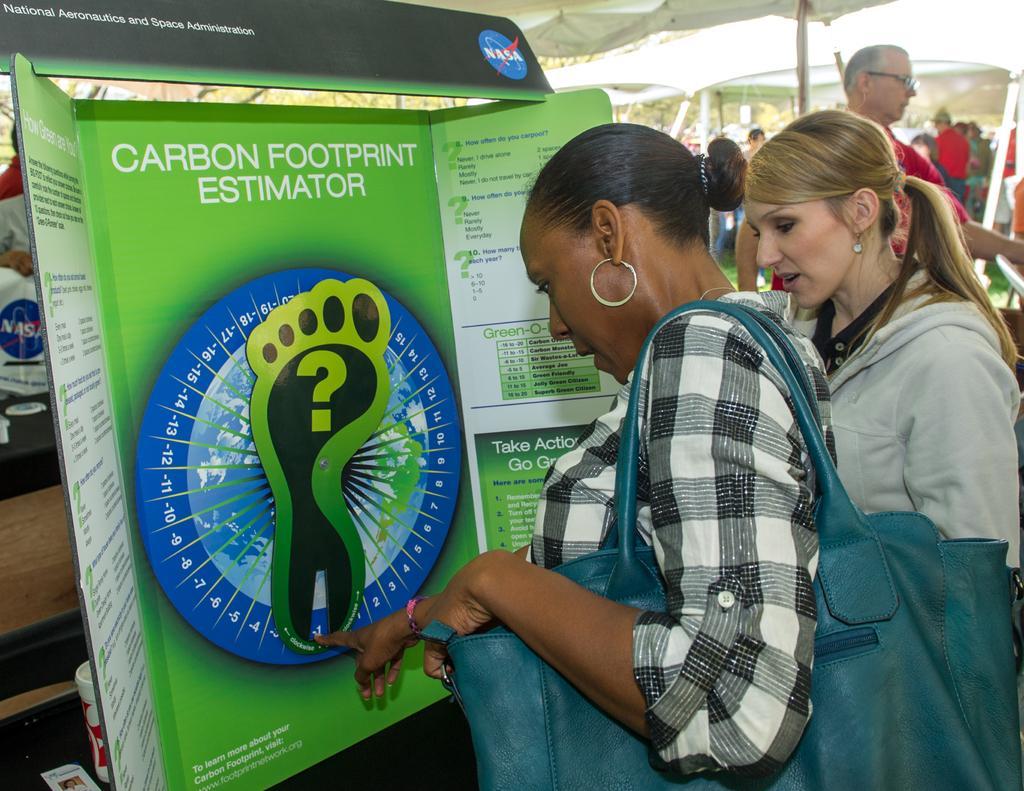Could you give a brief overview of what you see in this image? In this picture there are people and we can see boards and tent. We can see cup and card on the platform. In the background of the image we can see people and tents. 